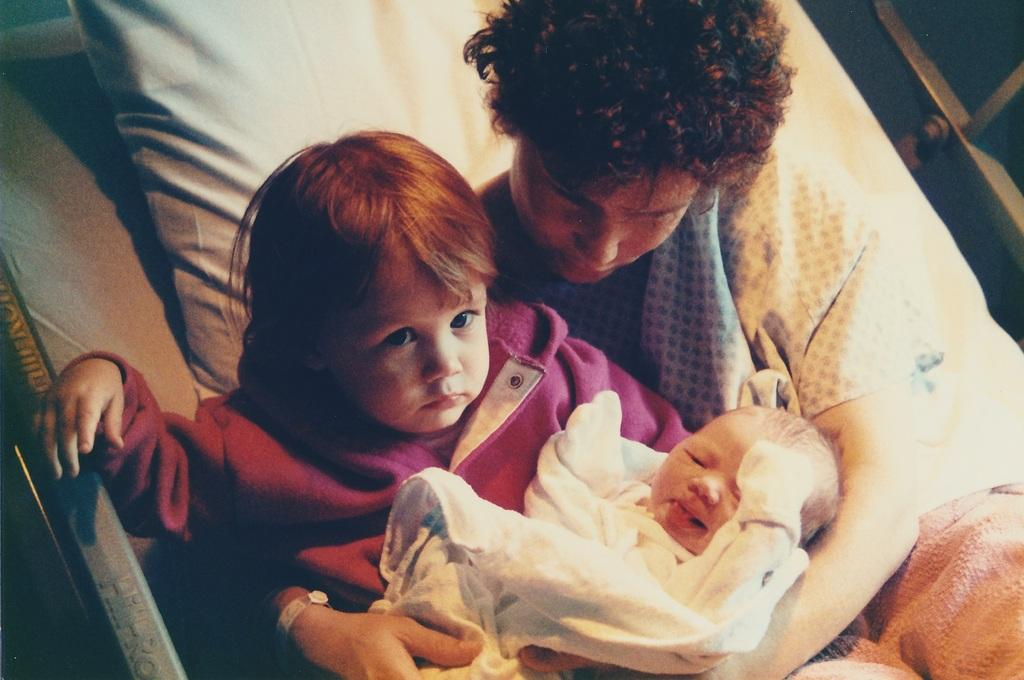Who is present in the image? There is a woman and a child in the image. What are the woman and child doing in the image? The woman and child are lying on a bed. What is the woman holding in the image? The woman is carrying a baby. What is on the bed in the image? There is a pillow on the bed. What type of material can be seen in the image? Metal poles are visible in the image. What type of stone is being used as a crib in the image? There is no stone or crib present in the image. Who is the porter in the image? There is no porter present in the image. 